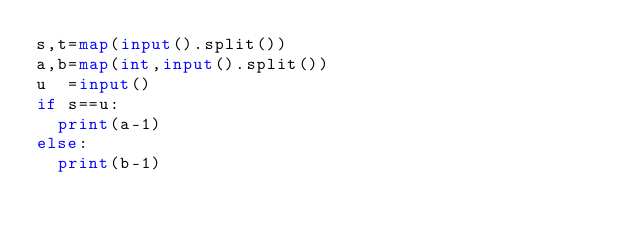Convert code to text. <code><loc_0><loc_0><loc_500><loc_500><_Python_>s,t=map(input().split())
a,b=map(int,input().split())
u  =input()
if s==u:
	print(a-1)
else:
	print(b-1)</code> 